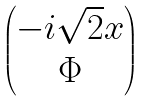Convert formula to latex. <formula><loc_0><loc_0><loc_500><loc_500>\begin{pmatrix} - i \sqrt { 2 } x \\ \Phi \end{pmatrix}</formula> 